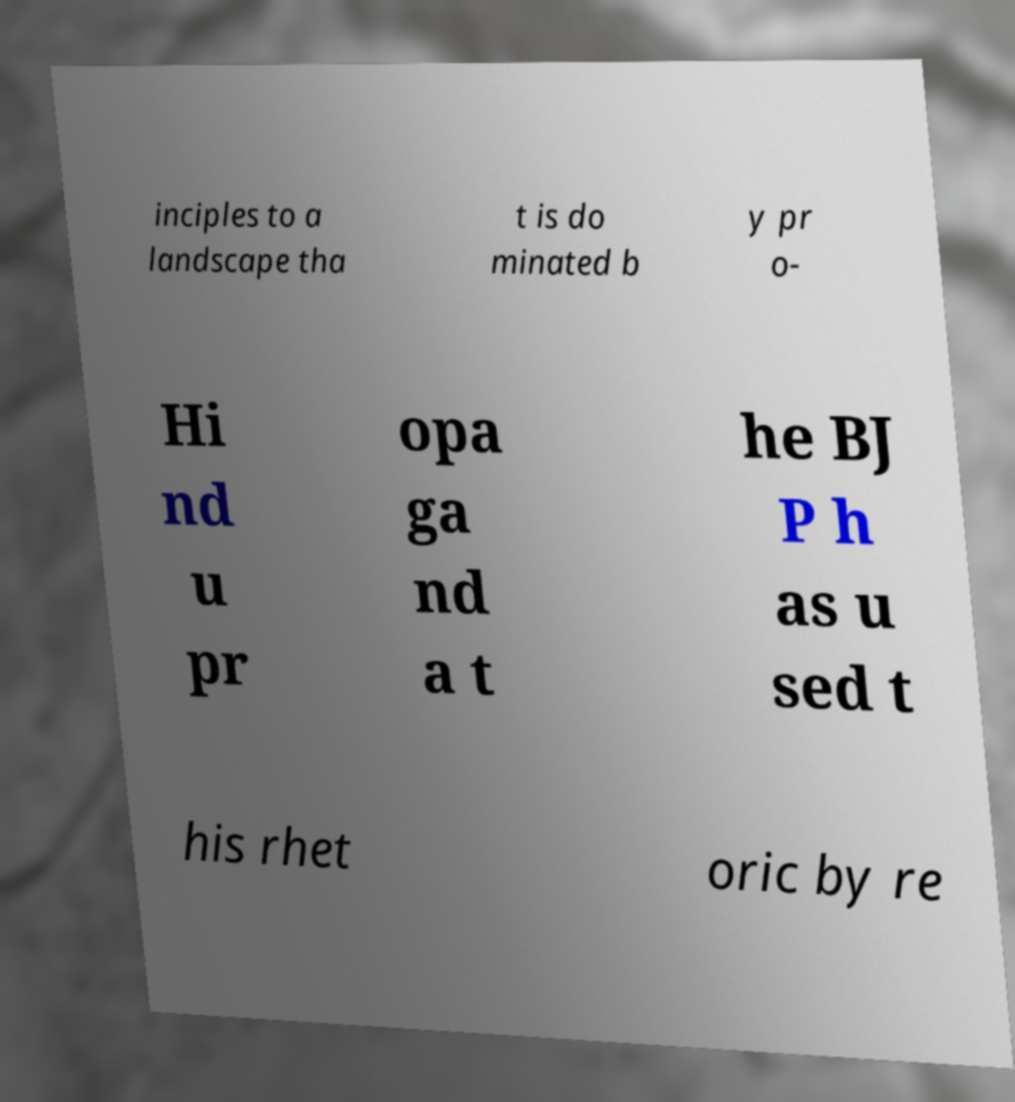Please read and relay the text visible in this image. What does it say? inciples to a landscape tha t is do minated b y pr o- Hi nd u pr opa ga nd a t he BJ P h as u sed t his rhet oric by re 